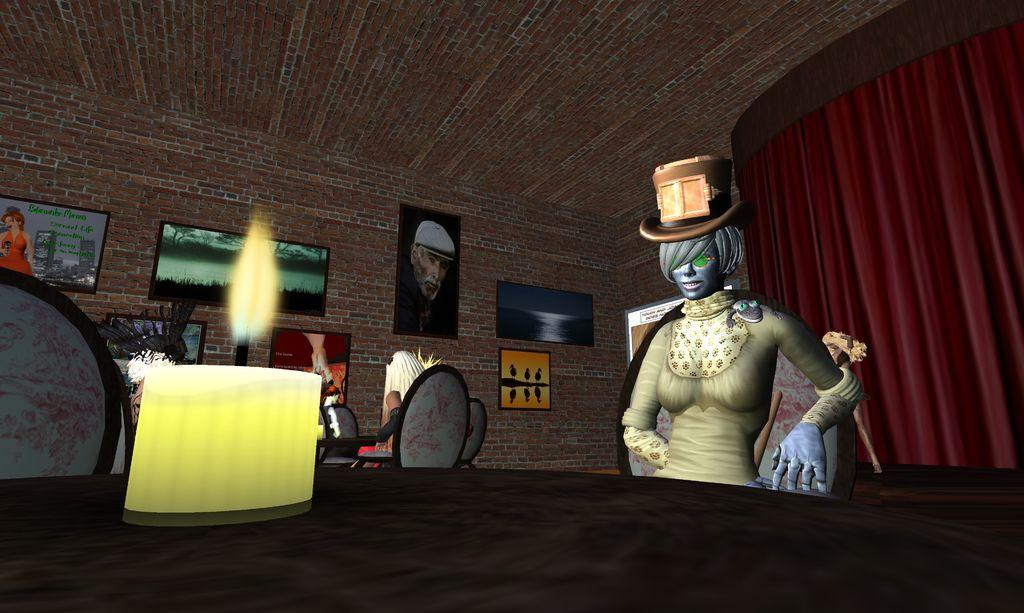What type of image is being described? The image is an animated picture. What can be seen in the image besides the animated aspect? There are pictures, a curtain, people, chairs, a table, a candle, and a brick wall in the image. What are the people in the image doing? People are sitting on chairs in the image. Where is the crib located in the image? There is no crib present in the image. What color is the head of the person sitting on the chair? The provided facts do not mention the color of the person's head, nor is there any information about the person's head at all. 